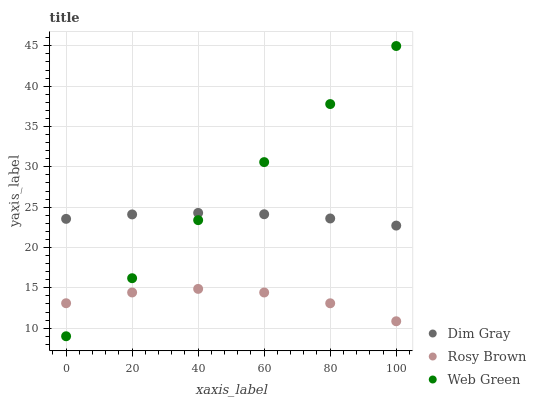Does Rosy Brown have the minimum area under the curve?
Answer yes or no. Yes. Does Web Green have the maximum area under the curve?
Answer yes or no. Yes. Does Dim Gray have the minimum area under the curve?
Answer yes or no. No. Does Dim Gray have the maximum area under the curve?
Answer yes or no. No. Is Web Green the smoothest?
Answer yes or no. Yes. Is Rosy Brown the roughest?
Answer yes or no. Yes. Is Dim Gray the smoothest?
Answer yes or no. No. Is Dim Gray the roughest?
Answer yes or no. No. Does Web Green have the lowest value?
Answer yes or no. Yes. Does Dim Gray have the lowest value?
Answer yes or no. No. Does Web Green have the highest value?
Answer yes or no. Yes. Does Dim Gray have the highest value?
Answer yes or no. No. Is Rosy Brown less than Dim Gray?
Answer yes or no. Yes. Is Dim Gray greater than Rosy Brown?
Answer yes or no. Yes. Does Web Green intersect Dim Gray?
Answer yes or no. Yes. Is Web Green less than Dim Gray?
Answer yes or no. No. Is Web Green greater than Dim Gray?
Answer yes or no. No. Does Rosy Brown intersect Dim Gray?
Answer yes or no. No. 